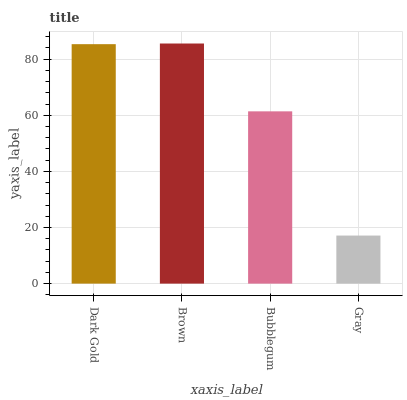Is Gray the minimum?
Answer yes or no. Yes. Is Brown the maximum?
Answer yes or no. Yes. Is Bubblegum the minimum?
Answer yes or no. No. Is Bubblegum the maximum?
Answer yes or no. No. Is Brown greater than Bubblegum?
Answer yes or no. Yes. Is Bubblegum less than Brown?
Answer yes or no. Yes. Is Bubblegum greater than Brown?
Answer yes or no. No. Is Brown less than Bubblegum?
Answer yes or no. No. Is Dark Gold the high median?
Answer yes or no. Yes. Is Bubblegum the low median?
Answer yes or no. Yes. Is Brown the high median?
Answer yes or no. No. Is Brown the low median?
Answer yes or no. No. 